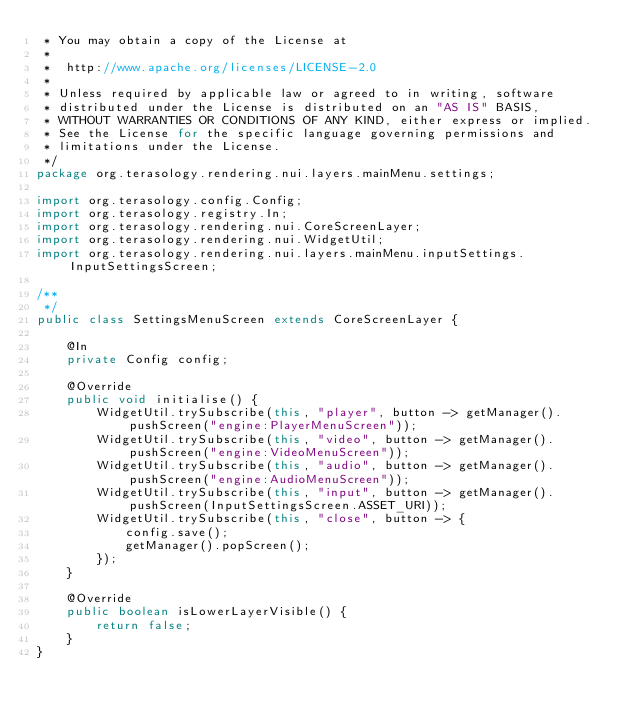Convert code to text. <code><loc_0><loc_0><loc_500><loc_500><_Java_> * You may obtain a copy of the License at
 *
 *  http://www.apache.org/licenses/LICENSE-2.0
 *
 * Unless required by applicable law or agreed to in writing, software
 * distributed under the License is distributed on an "AS IS" BASIS,
 * WITHOUT WARRANTIES OR CONDITIONS OF ANY KIND, either express or implied.
 * See the License for the specific language governing permissions and
 * limitations under the License.
 */
package org.terasology.rendering.nui.layers.mainMenu.settings;

import org.terasology.config.Config;
import org.terasology.registry.In;
import org.terasology.rendering.nui.CoreScreenLayer;
import org.terasology.rendering.nui.WidgetUtil;
import org.terasology.rendering.nui.layers.mainMenu.inputSettings.InputSettingsScreen;

/**
 */
public class SettingsMenuScreen extends CoreScreenLayer {

    @In
    private Config config;

    @Override
    public void initialise() {
        WidgetUtil.trySubscribe(this, "player", button -> getManager().pushScreen("engine:PlayerMenuScreen"));
        WidgetUtil.trySubscribe(this, "video", button -> getManager().pushScreen("engine:VideoMenuScreen"));
        WidgetUtil.trySubscribe(this, "audio", button -> getManager().pushScreen("engine:AudioMenuScreen"));
        WidgetUtil.trySubscribe(this, "input", button -> getManager().pushScreen(InputSettingsScreen.ASSET_URI));
        WidgetUtil.trySubscribe(this, "close", button -> {
            config.save();
            getManager().popScreen();
        });
    }

    @Override
    public boolean isLowerLayerVisible() {
        return false;
    }
}
</code> 